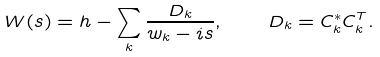<formula> <loc_0><loc_0><loc_500><loc_500>W ( s ) = h - \sum _ { k } \frac { D _ { k } } { w _ { k } - i s } , \quad D _ { k } = C _ { k } ^ { * } C _ { k } ^ { T } .</formula> 